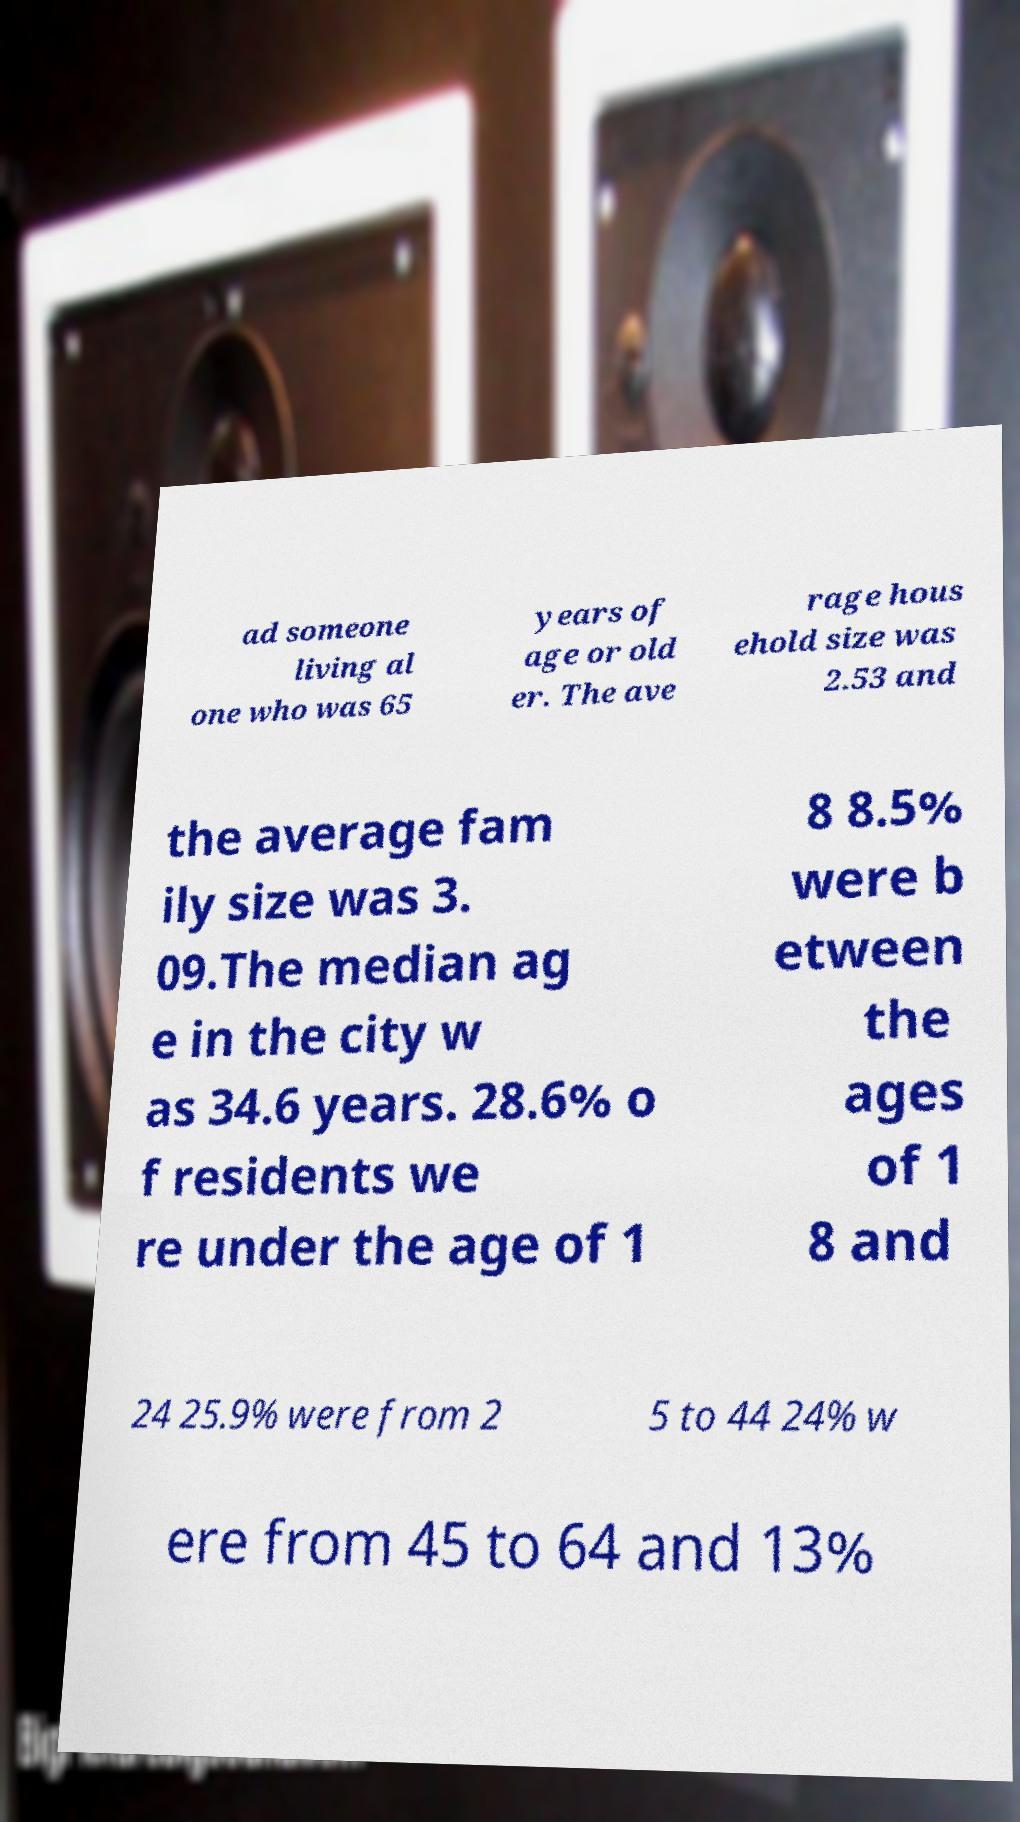Can you accurately transcribe the text from the provided image for me? ad someone living al one who was 65 years of age or old er. The ave rage hous ehold size was 2.53 and the average fam ily size was 3. 09.The median ag e in the city w as 34.6 years. 28.6% o f residents we re under the age of 1 8 8.5% were b etween the ages of 1 8 and 24 25.9% were from 2 5 to 44 24% w ere from 45 to 64 and 13% 